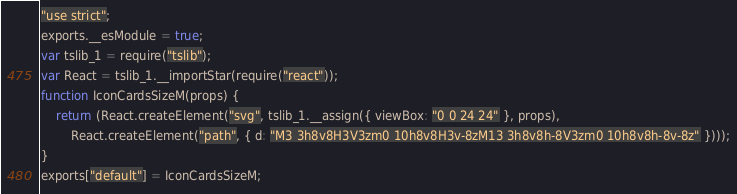Convert code to text. <code><loc_0><loc_0><loc_500><loc_500><_JavaScript_>"use strict";
exports.__esModule = true;
var tslib_1 = require("tslib");
var React = tslib_1.__importStar(require("react"));
function IconCardsSizeM(props) {
    return (React.createElement("svg", tslib_1.__assign({ viewBox: "0 0 24 24" }, props),
        React.createElement("path", { d: "M3 3h8v8H3V3zm0 10h8v8H3v-8zM13 3h8v8h-8V3zm0 10h8v8h-8v-8z" })));
}
exports["default"] = IconCardsSizeM;
</code> 